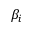Convert formula to latex. <formula><loc_0><loc_0><loc_500><loc_500>\beta _ { i }</formula> 